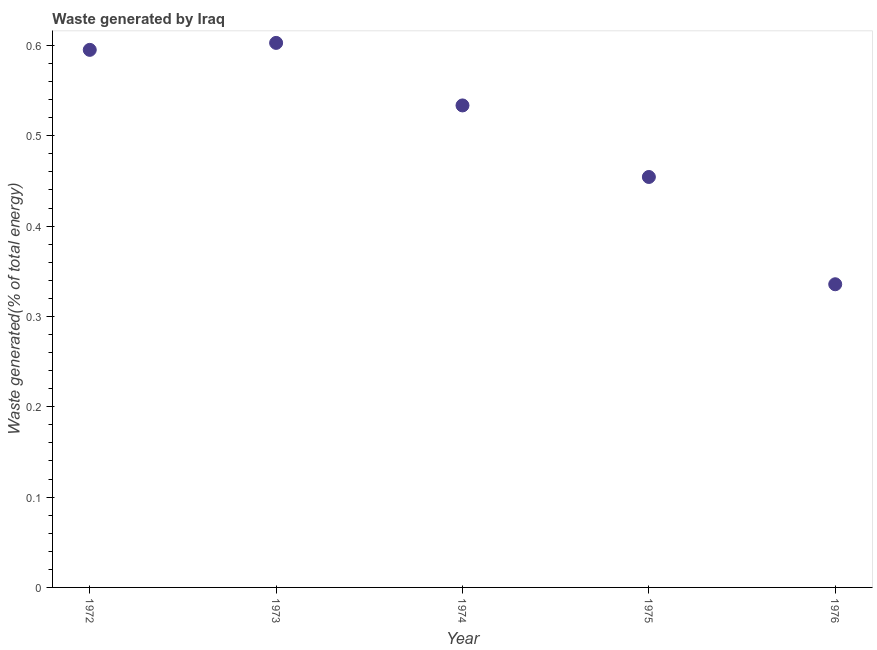What is the amount of waste generated in 1972?
Give a very brief answer. 0.6. Across all years, what is the maximum amount of waste generated?
Ensure brevity in your answer.  0.6. Across all years, what is the minimum amount of waste generated?
Give a very brief answer. 0.34. In which year was the amount of waste generated maximum?
Ensure brevity in your answer.  1973. In which year was the amount of waste generated minimum?
Offer a terse response. 1976. What is the sum of the amount of waste generated?
Keep it short and to the point. 2.52. What is the difference between the amount of waste generated in 1972 and 1975?
Offer a terse response. 0.14. What is the average amount of waste generated per year?
Make the answer very short. 0.5. What is the median amount of waste generated?
Your answer should be very brief. 0.53. In how many years, is the amount of waste generated greater than 0.30000000000000004 %?
Provide a succinct answer. 5. What is the ratio of the amount of waste generated in 1972 to that in 1976?
Make the answer very short. 1.77. Is the difference between the amount of waste generated in 1974 and 1976 greater than the difference between any two years?
Provide a short and direct response. No. What is the difference between the highest and the second highest amount of waste generated?
Offer a terse response. 0.01. What is the difference between the highest and the lowest amount of waste generated?
Offer a very short reply. 0.27. In how many years, is the amount of waste generated greater than the average amount of waste generated taken over all years?
Your answer should be very brief. 3. What is the difference between two consecutive major ticks on the Y-axis?
Make the answer very short. 0.1. Are the values on the major ticks of Y-axis written in scientific E-notation?
Offer a very short reply. No. Does the graph contain any zero values?
Give a very brief answer. No. What is the title of the graph?
Provide a succinct answer. Waste generated by Iraq. What is the label or title of the Y-axis?
Give a very brief answer. Waste generated(% of total energy). What is the Waste generated(% of total energy) in 1972?
Make the answer very short. 0.6. What is the Waste generated(% of total energy) in 1973?
Your answer should be very brief. 0.6. What is the Waste generated(% of total energy) in 1974?
Ensure brevity in your answer.  0.53. What is the Waste generated(% of total energy) in 1975?
Provide a succinct answer. 0.45. What is the Waste generated(% of total energy) in 1976?
Your answer should be compact. 0.34. What is the difference between the Waste generated(% of total energy) in 1972 and 1973?
Ensure brevity in your answer.  -0.01. What is the difference between the Waste generated(% of total energy) in 1972 and 1974?
Provide a succinct answer. 0.06. What is the difference between the Waste generated(% of total energy) in 1972 and 1975?
Offer a terse response. 0.14. What is the difference between the Waste generated(% of total energy) in 1972 and 1976?
Make the answer very short. 0.26. What is the difference between the Waste generated(% of total energy) in 1973 and 1974?
Keep it short and to the point. 0.07. What is the difference between the Waste generated(% of total energy) in 1973 and 1975?
Provide a short and direct response. 0.15. What is the difference between the Waste generated(% of total energy) in 1973 and 1976?
Offer a very short reply. 0.27. What is the difference between the Waste generated(% of total energy) in 1974 and 1975?
Ensure brevity in your answer.  0.08. What is the difference between the Waste generated(% of total energy) in 1974 and 1976?
Provide a succinct answer. 0.2. What is the difference between the Waste generated(% of total energy) in 1975 and 1976?
Keep it short and to the point. 0.12. What is the ratio of the Waste generated(% of total energy) in 1972 to that in 1974?
Make the answer very short. 1.11. What is the ratio of the Waste generated(% of total energy) in 1972 to that in 1975?
Offer a very short reply. 1.31. What is the ratio of the Waste generated(% of total energy) in 1972 to that in 1976?
Ensure brevity in your answer.  1.77. What is the ratio of the Waste generated(% of total energy) in 1973 to that in 1974?
Ensure brevity in your answer.  1.13. What is the ratio of the Waste generated(% of total energy) in 1973 to that in 1975?
Your response must be concise. 1.33. What is the ratio of the Waste generated(% of total energy) in 1973 to that in 1976?
Give a very brief answer. 1.8. What is the ratio of the Waste generated(% of total energy) in 1974 to that in 1975?
Provide a short and direct response. 1.17. What is the ratio of the Waste generated(% of total energy) in 1974 to that in 1976?
Your answer should be compact. 1.59. What is the ratio of the Waste generated(% of total energy) in 1975 to that in 1976?
Offer a terse response. 1.35. 